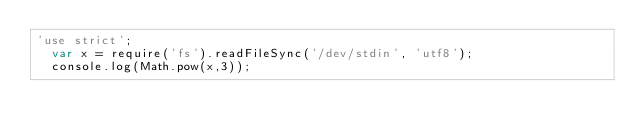<code> <loc_0><loc_0><loc_500><loc_500><_JavaScript_>'use strict';
  var x = require('fs').readFileSync('/dev/stdin', 'utf8');
  console.log(Math.pow(x,3));</code> 